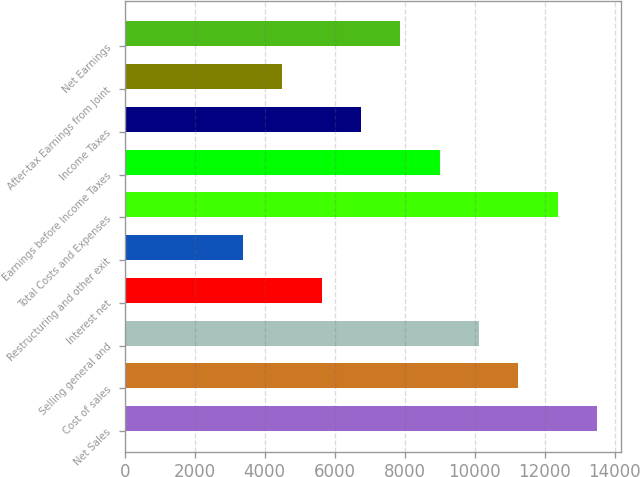Convert chart to OTSL. <chart><loc_0><loc_0><loc_500><loc_500><bar_chart><fcel>Net Sales<fcel>Cost of sales<fcel>Selling general and<fcel>Interest net<fcel>Restructuring and other exit<fcel>Total Costs and Expenses<fcel>Earnings before Income Taxes<fcel>Income Taxes<fcel>After-tax Earnings from Joint<fcel>Net Earnings<nl><fcel>13492.6<fcel>11244<fcel>10119.8<fcel>5622.64<fcel>3374.08<fcel>12368.3<fcel>8995.48<fcel>6746.92<fcel>4498.36<fcel>7871.2<nl></chart> 